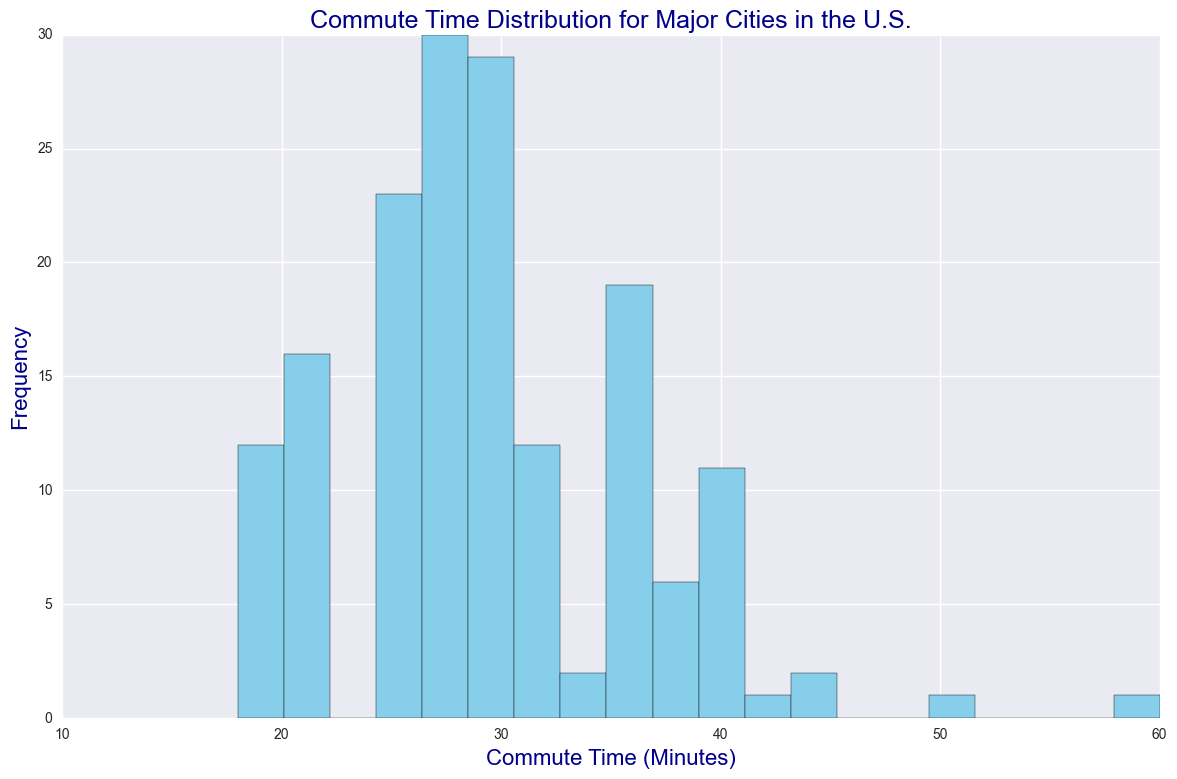What's the most common commute time range? To determine the most common commute time range, one should look at the highest bar in the histogram as it represents the mode of the distribution.
Answer: 30-35 minutes Which commute time range has the least frequency? Upon examining the histogram, the lowest bars represent the least frequent commute times. These are close to the edges of the distribution.
Answer: 50-55 minutes How does the frequency of commute times between 20-25 minutes compare to those between 40-45 minutes? To answer this comparison question, observe the bars corresponding to the ranges 20-25 minutes and 40-45 minutes. The height of the bars in the 20-25 minute range is higher, indicating more frequency.
Answer: 20-25 minutes is higher What is the distribution spread of the data? By examining the width of the histogram, one can see that the data ranges from the shortest, around 15 minutes, to the longest commute time, around 60 minutes.
Answer: 15-60 minutes What is the median commute time range? The median commute time would lie in the range where the cumulative frequency reaches its midpoint. By examining the histogram, this is roughly around the central bars.
Answer: 30-35 minutes Which time range has a higher frequency: 25-30 minutes or 35-40 minutes? Compare the heights of the bars for these two ranges. The heights of the bars for 25-30 minutes are generally higher, indicating this range has a higher frequency.
Answer: 25-30 minutes What is the relative frequency difference between the 35-40 minute range and the 40-45 minute range? To determine the relative difference, subtract the frequency of the 40-45 minute range from the 35-40 minute range and then divide by the 35-40 minute frequency. By visual inspection, the difference is notable but not extreme.
Answer: Roughly -20% What does the skewness of the histogram indicate? Observing the shape of the histogram, if the right tail (longer commute times) is longer than the left tail (shorter commute times), the distribution is right-skewed.
Answer: Right-skewed How does the frequency of commute times in the range 15-20 minutes compare to the range 45-50 minutes? By checking the heights of the bars for 15-20 minutes and 45-50 minutes ranges, one can see that the 15-20 minutes range has a lower frequency.
Answer: 45-50 minutes is higher 